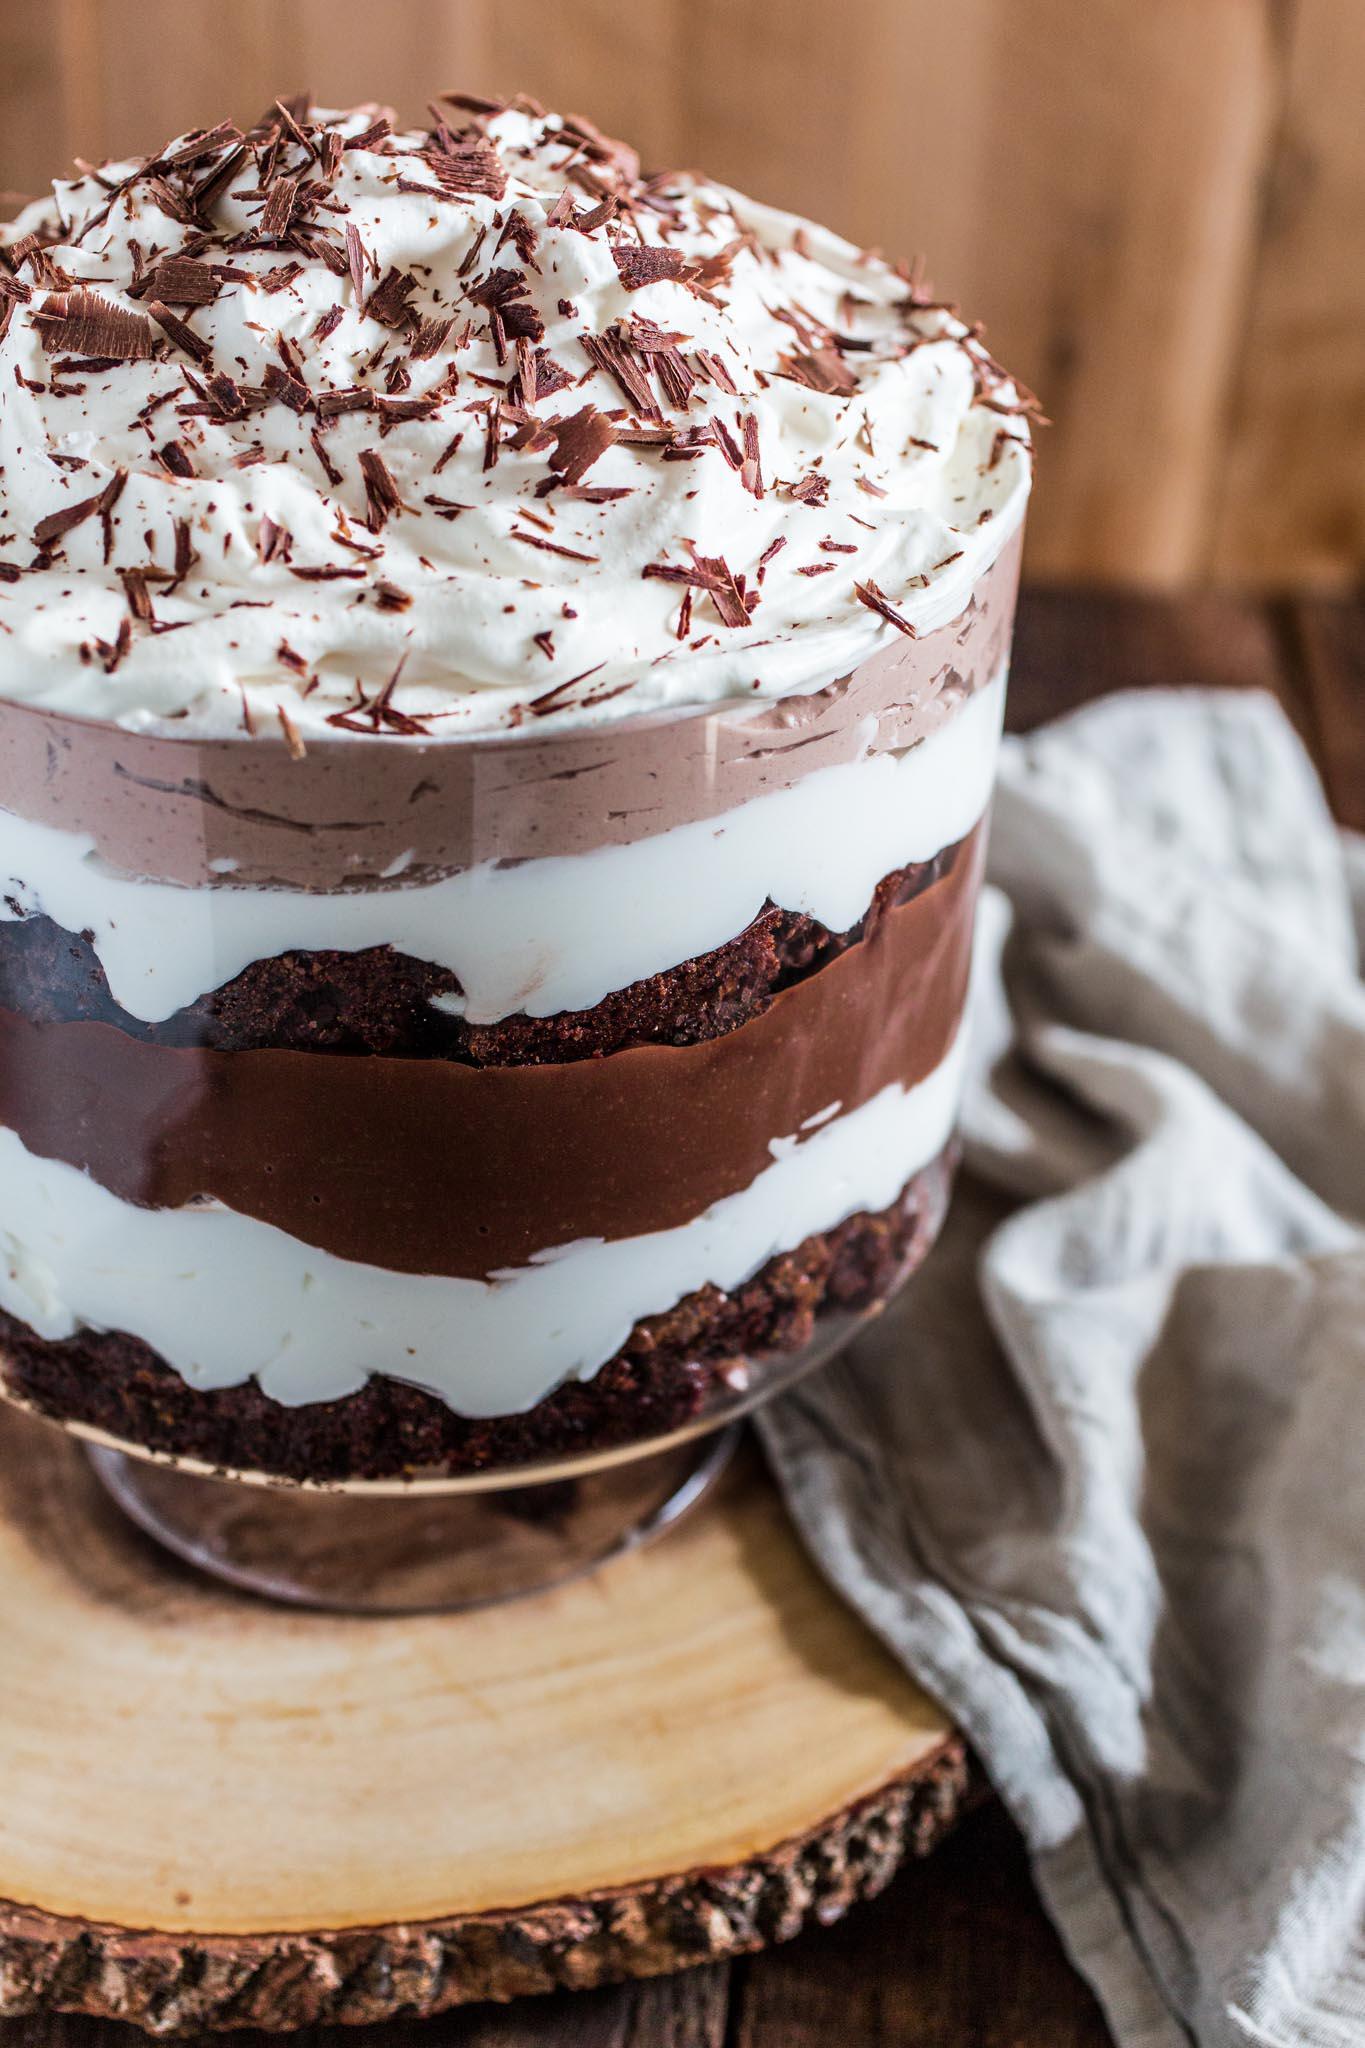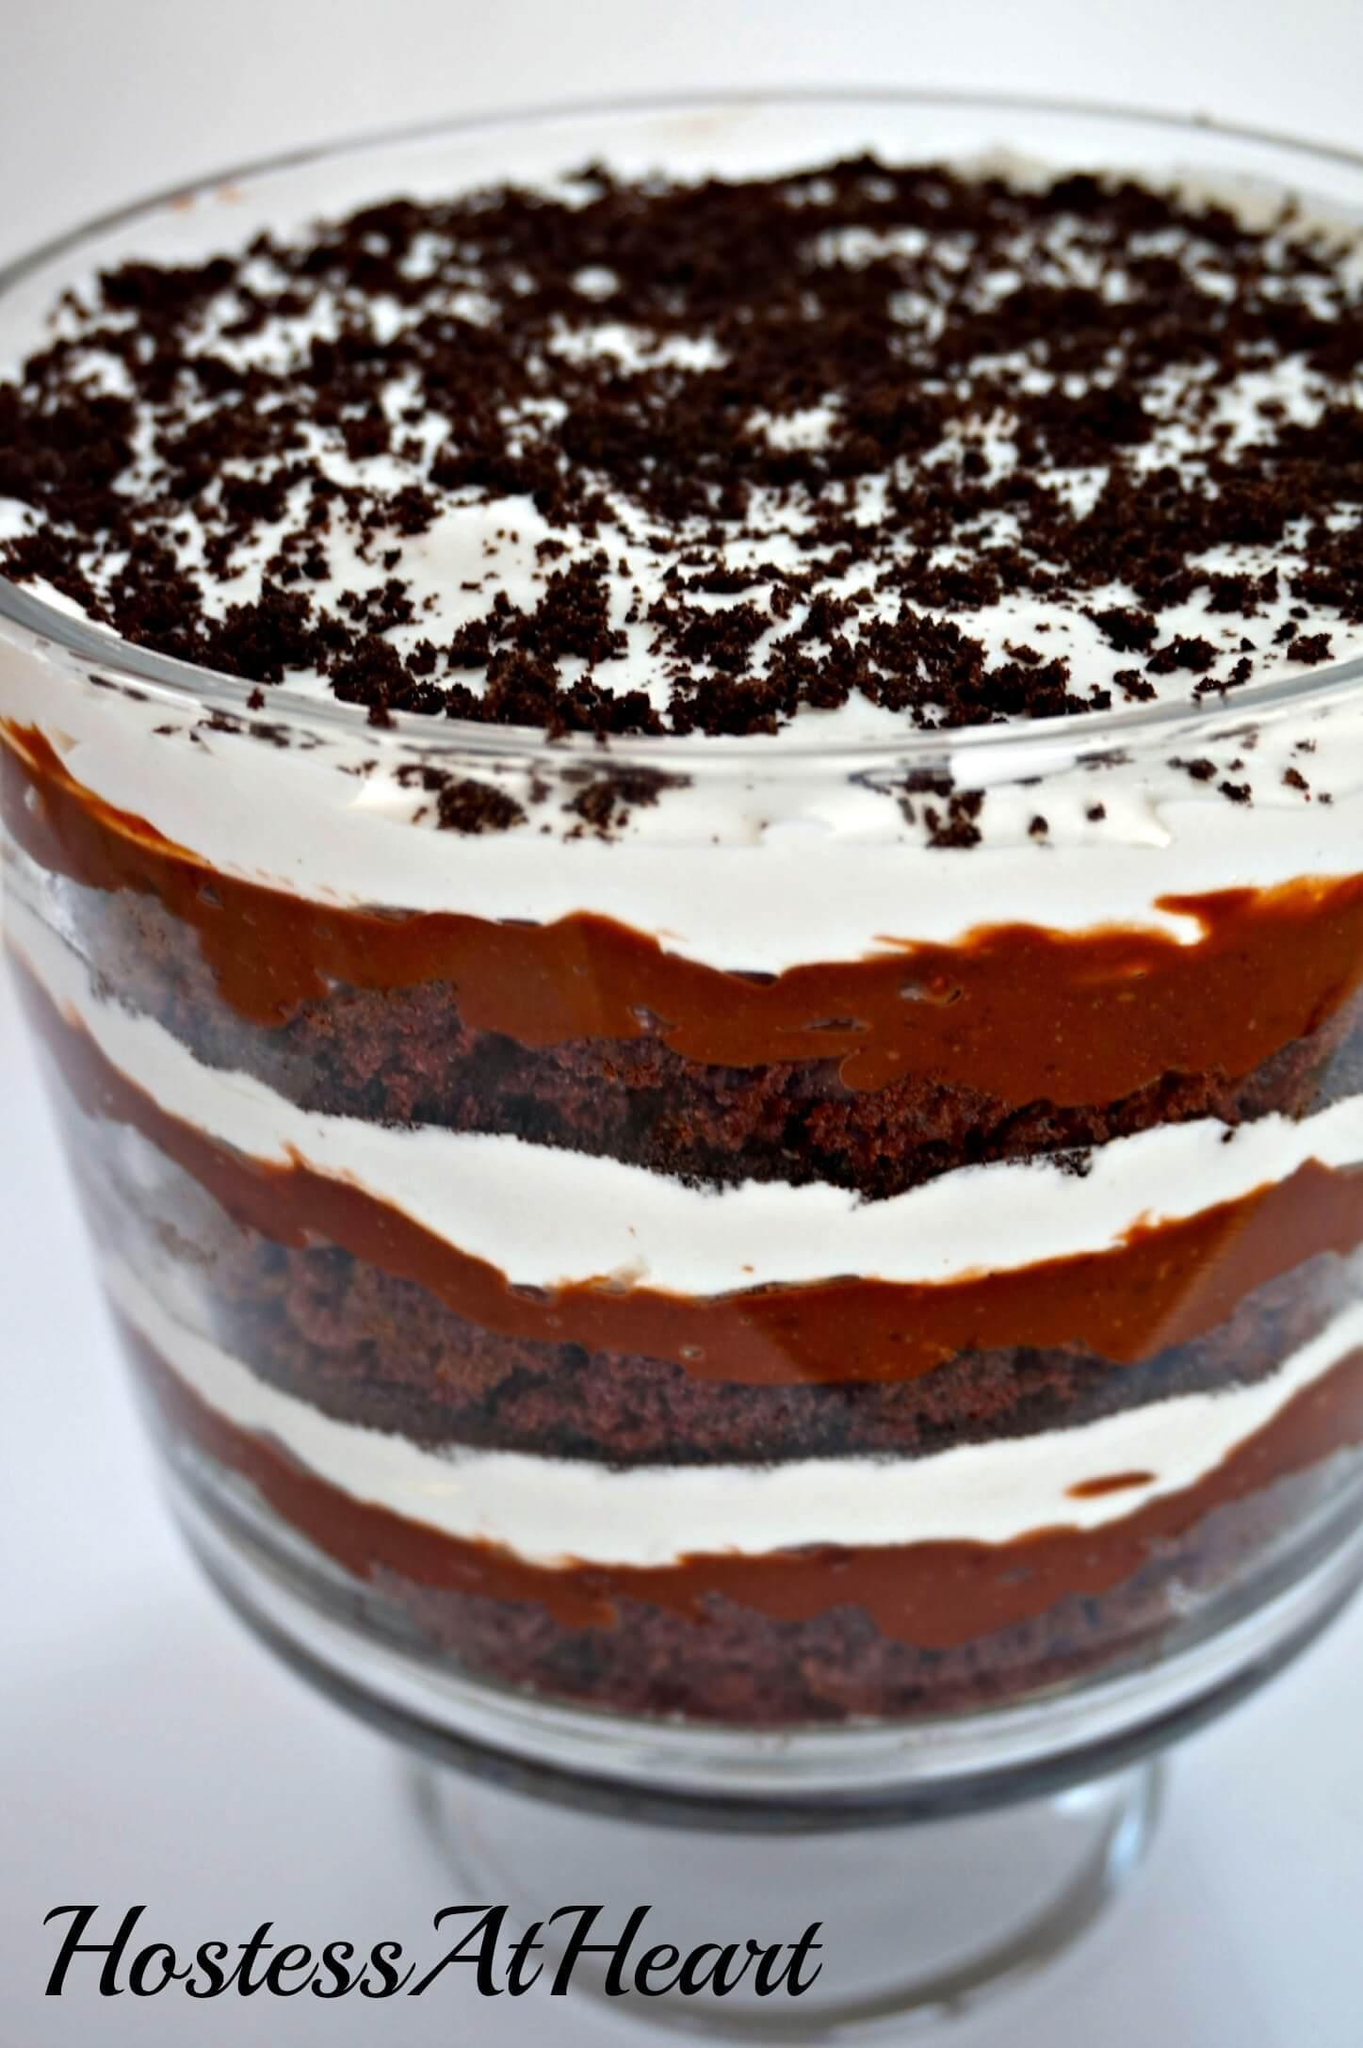The first image is the image on the left, the second image is the image on the right. Considering the images on both sides, is "There are two desserts in one of the images" valid? Answer yes or no. No. The first image is the image on the left, the second image is the image on the right. Considering the images on both sides, is "Two large chocolate desserts have multiple chocolate and white layers, with sprinkles in the top white layer." valid? Answer yes or no. Yes. 